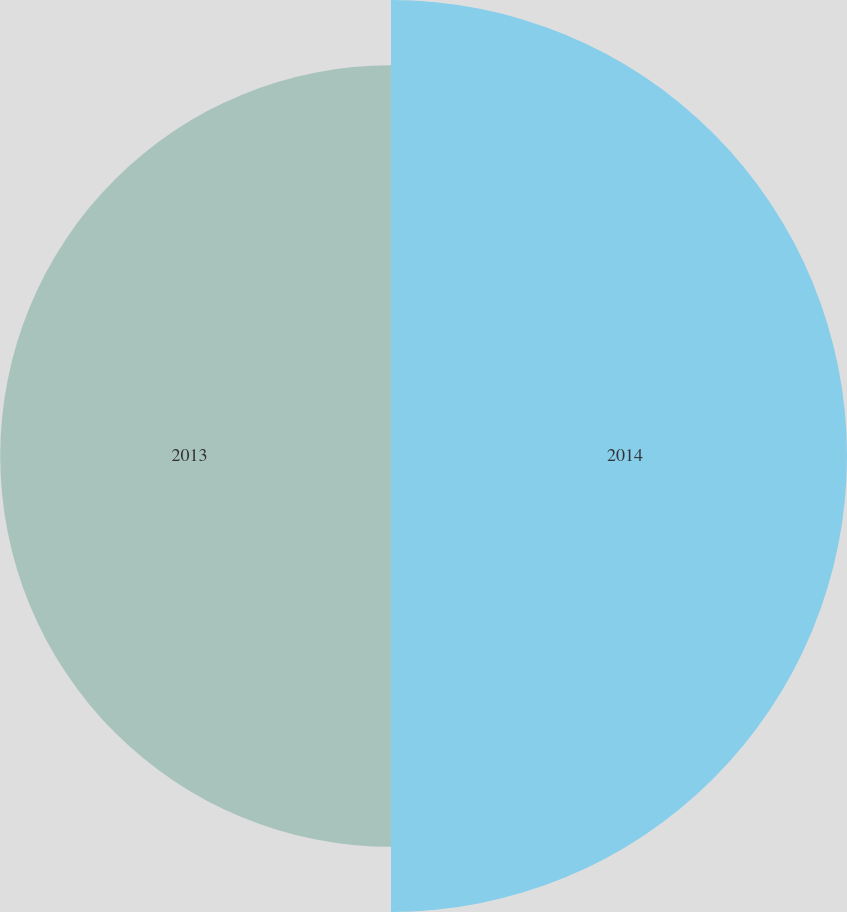<chart> <loc_0><loc_0><loc_500><loc_500><pie_chart><fcel>2014<fcel>2013<nl><fcel>53.85%<fcel>46.15%<nl></chart> 